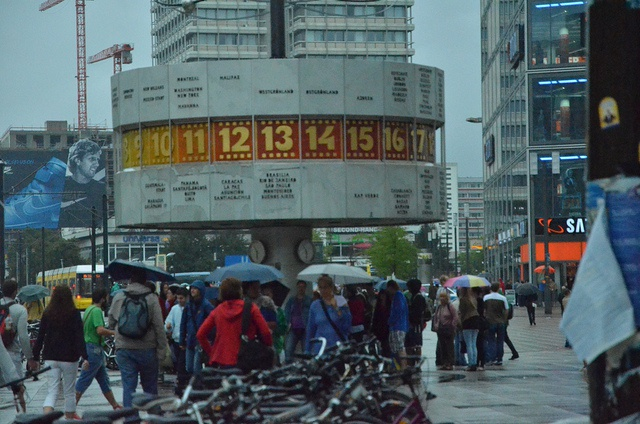Describe the objects in this image and their specific colors. I can see people in darkgray, black, gray, and purple tones, people in darkgray, black, gray, navy, and blue tones, people in darkgray, black, and gray tones, people in darkgray, maroon, black, and brown tones, and bicycle in darkgray, black, gray, and purple tones in this image. 